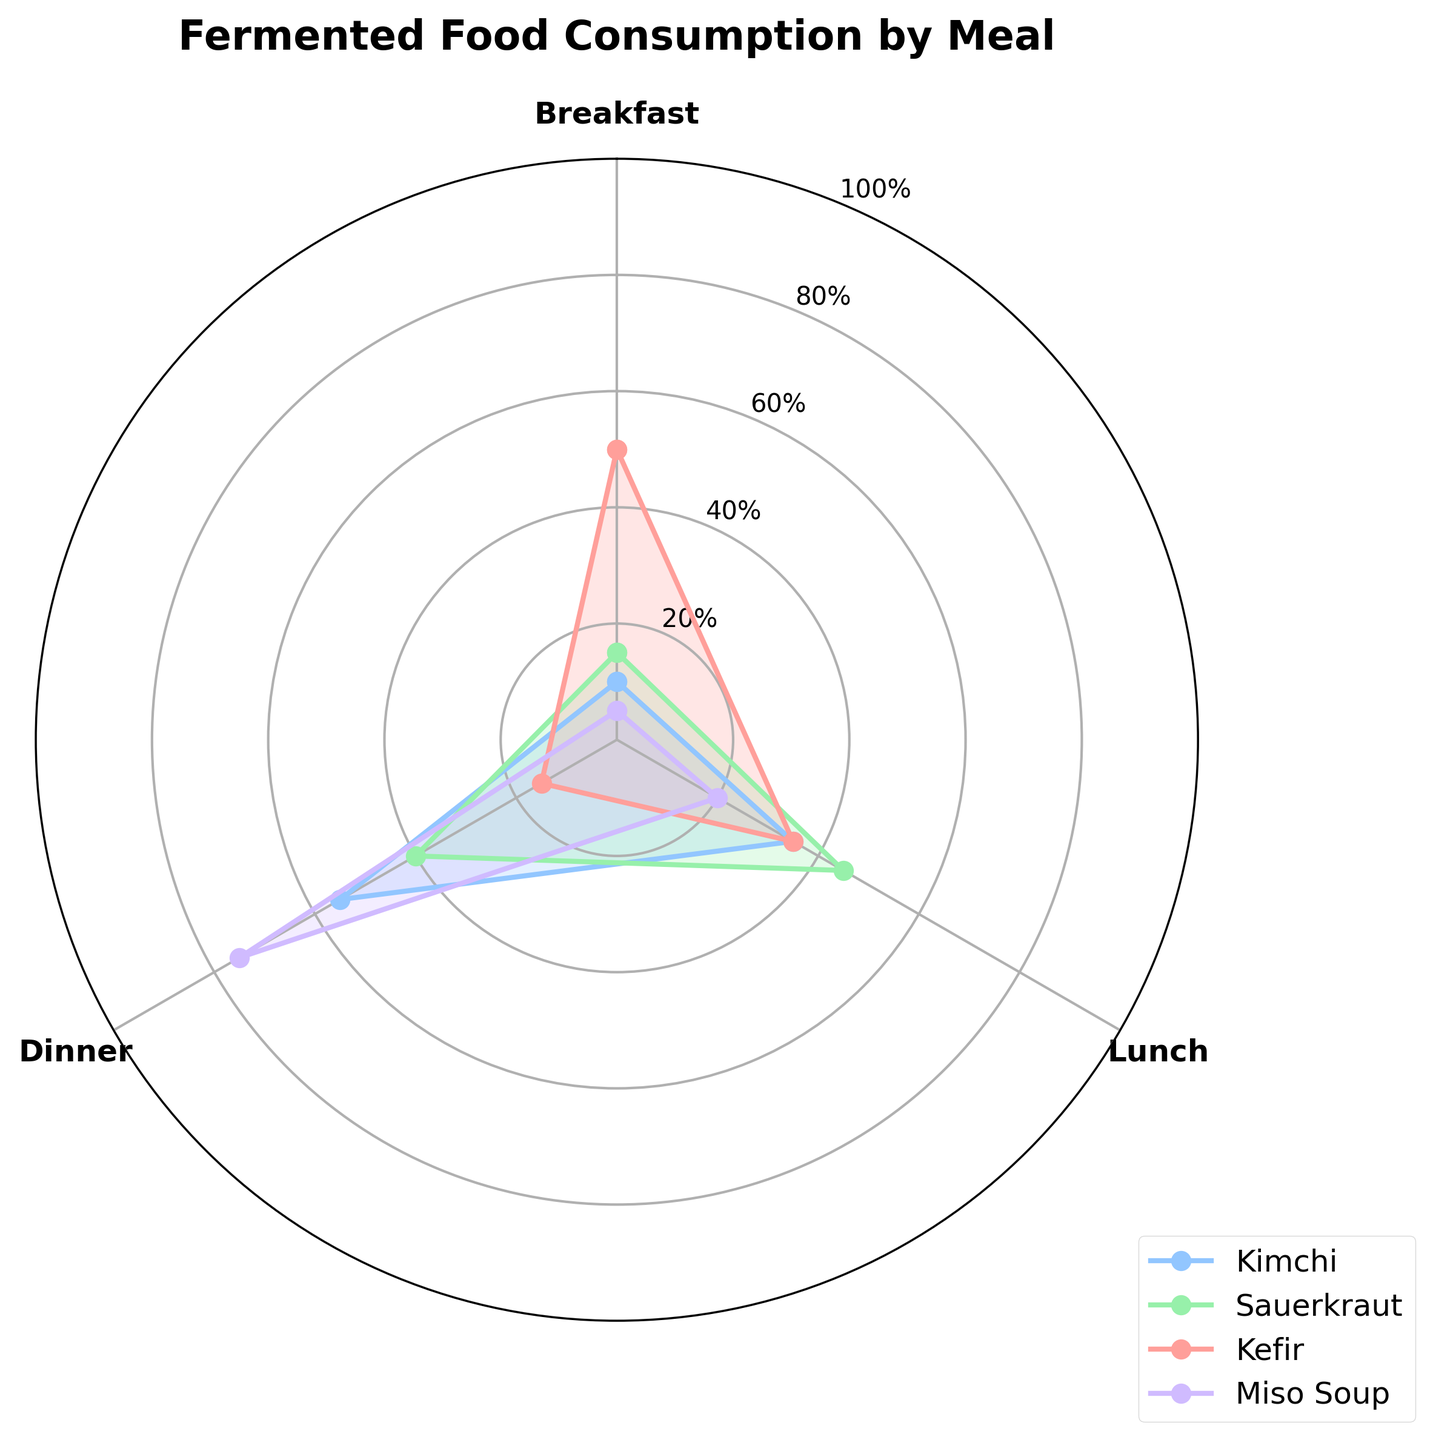What is the title of the figure? The title is at the top of the figure and it reads "Fermented Food Consumption by Meal".
Answer: Fermented Food Consumption by Meal Which fermented food category has the highest percentage consumed during breakfast? By looking at the lengths of the radial lines for breakfast, Kefir has the longest line.
Answer: Kefir What is the percentage of Kimchi consumed during dinner? The radial line for Kimchi at the dinner section shows the percentage at 55%.
Answer: 55% How does the percentage of Sauerkraut consumed for lunch compare to that for dinner? The radial line for lunch falls at 45% and for dinner at 40%. Comparing these, Sauerkraut is consumed more at lunch than dinner.
Answer: More at lunch What is the sum of all percentages for Miso Soup across all meals? Adding the values for Miso Soup: 5% (Breakfast) + 20% (Lunch) + 75% (Dinner) = 100%.
Answer: 100% Which fermented food has the lowest consumption percentage during breakfast? Looking at the shortest radial lines for breakfast, Miso Soup has the shortest line at 5%.
Answer: Miso Soup What is the average percentage of Kefir consumed across all meals? Adding up the percentages for Kefir and then dividing by the number of meals: (50% + 35% + 15%) / 3 = 33.33%.
Answer: 33.33% Which two meals have the closest percentage of Sauerkraut consumption, and what are those percentages? Observing the percentages for Sauerkraut: Breakfast (15%), Lunch (45%), Dinner (40%), the closest values are for Lunch and Dinner at 45% and 40%, respectively.
Answer: Lunch and Dinner, 45% and 40% Which meal shows the greatest variation in fermented food consumption percentages? Observing the range of values for each meal: Breakfast (5% to 50%), Lunch (20% to 45%), Dinner (15% to 75%), Dinner shows the largest range from 15% to 75%.
Answer: Dinner What is the difference in consumption of Kimchi between lunch and dinner? Subtracting the percentage for lunch from that of dinner for Kimchi: 55% - 35% = 20%.
Answer: 20% 